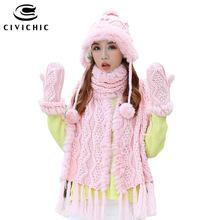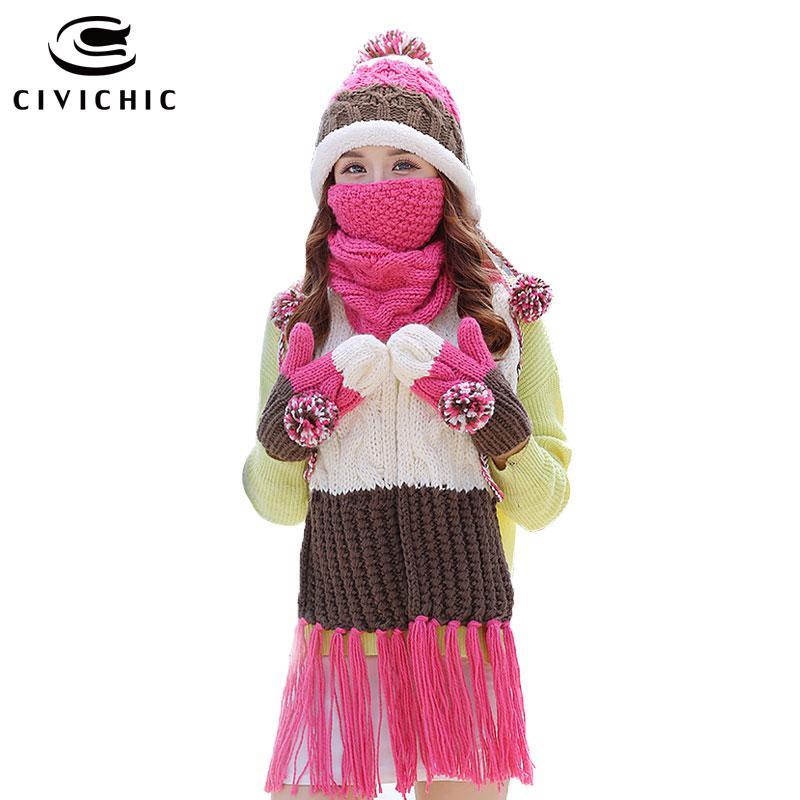The first image is the image on the left, the second image is the image on the right. Analyze the images presented: Is the assertion "There is a girl with her mouth covered." valid? Answer yes or no. Yes. The first image is the image on the left, the second image is the image on the right. For the images displayed, is the sentence "One woman is wearing a large dark pink, brown and white scarf with matching gloves and hat that has a pompom." factually correct? Answer yes or no. Yes. 